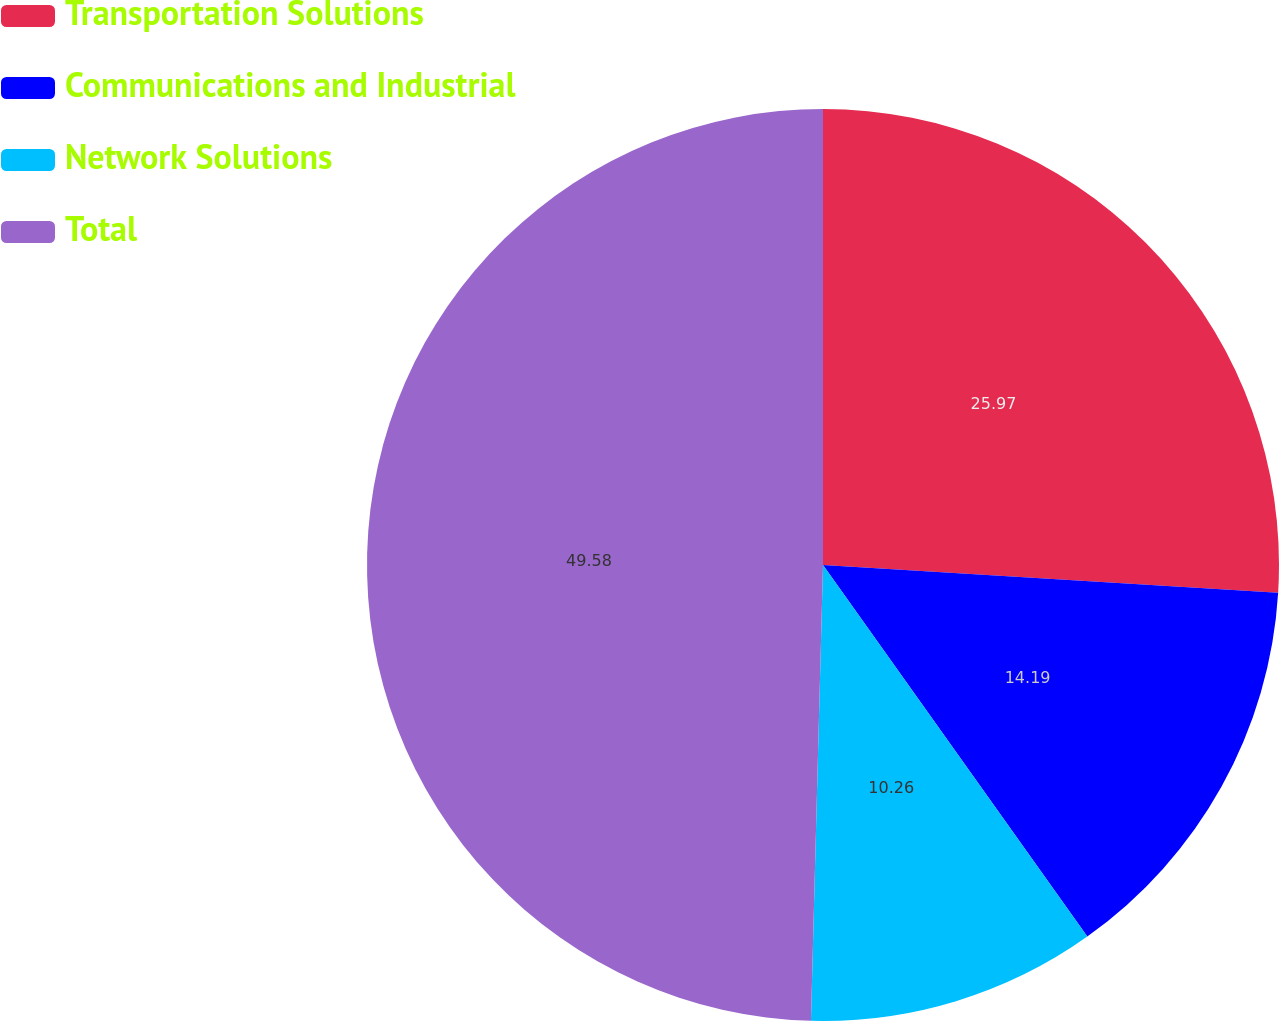Convert chart to OTSL. <chart><loc_0><loc_0><loc_500><loc_500><pie_chart><fcel>Transportation Solutions<fcel>Communications and Industrial<fcel>Network Solutions<fcel>Total<nl><fcel>25.97%<fcel>14.19%<fcel>10.26%<fcel>49.58%<nl></chart> 